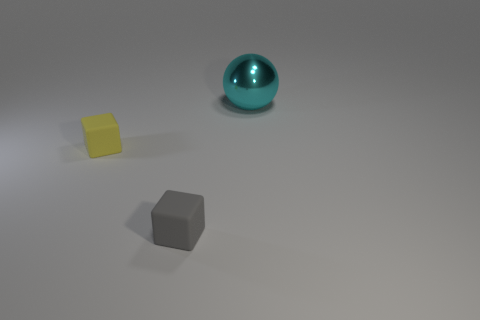Are the objects arranged in a particular pattern or order? The objects do not seem to follow a conventional pattern or order in their arrangement; instead, they are spaced apart in a manner that feels somewhat random. The positioning does, however, create a sense of balance within the frame, possibly intended to lead the viewer's eye from one object to another and create a visually pleasing composition. 